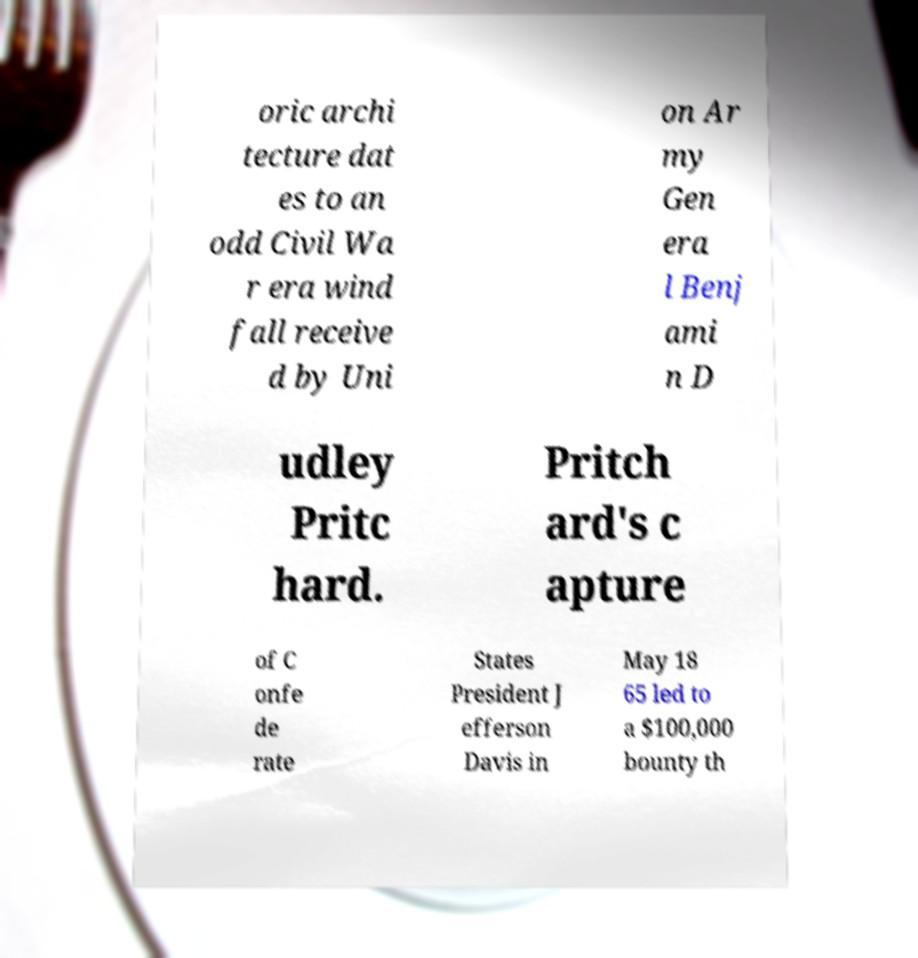Can you accurately transcribe the text from the provided image for me? oric archi tecture dat es to an odd Civil Wa r era wind fall receive d by Uni on Ar my Gen era l Benj ami n D udley Pritc hard. Pritch ard's c apture of C onfe de rate States President J efferson Davis in May 18 65 led to a $100,000 bounty th 